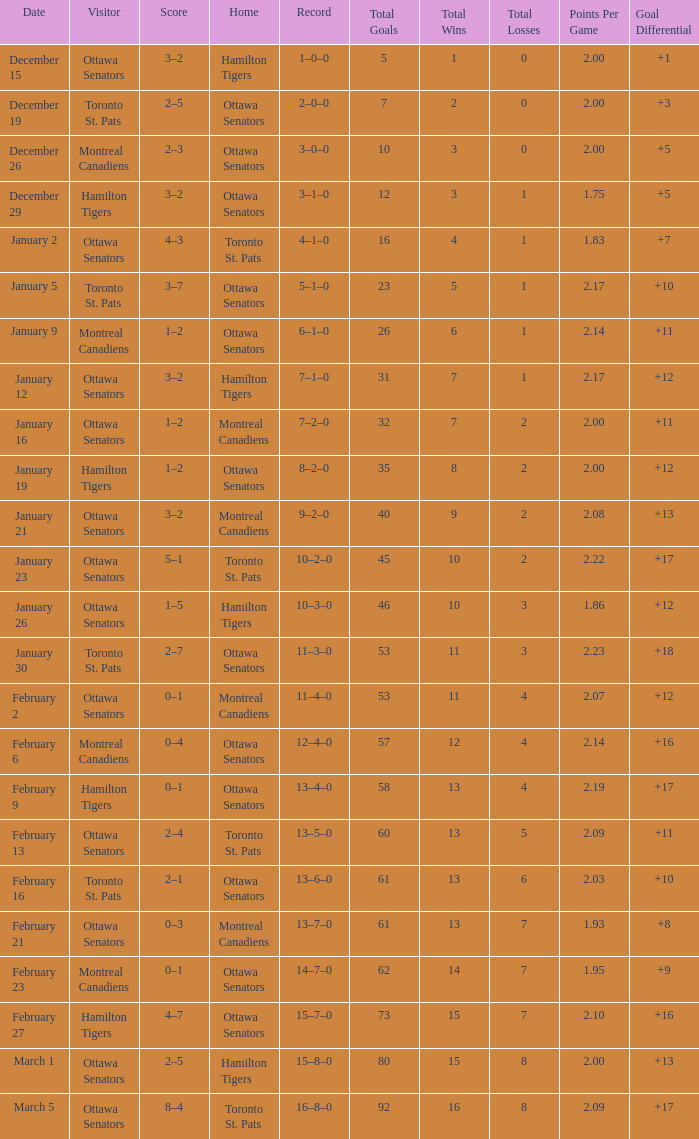What was the score on January 12? 3–2. 